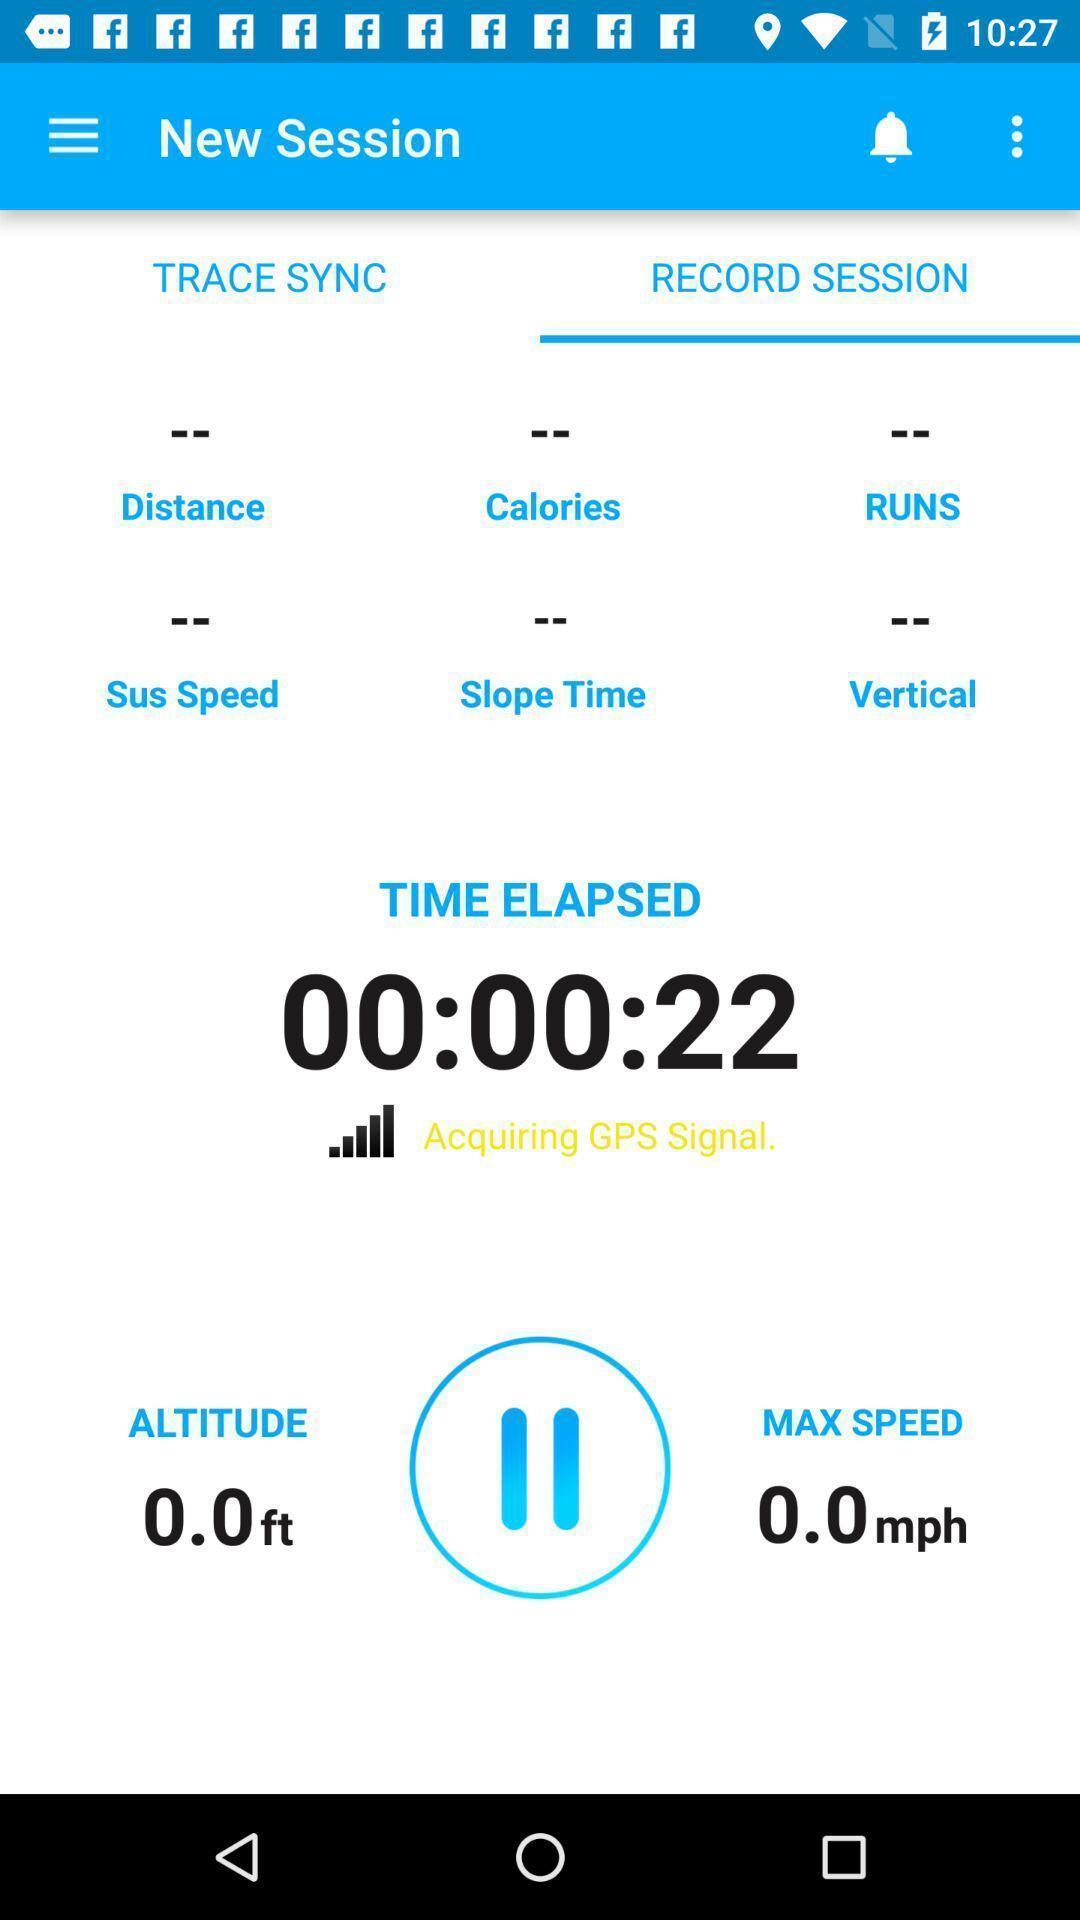What is the overall content of this screenshot? Time elapsed in record session. 